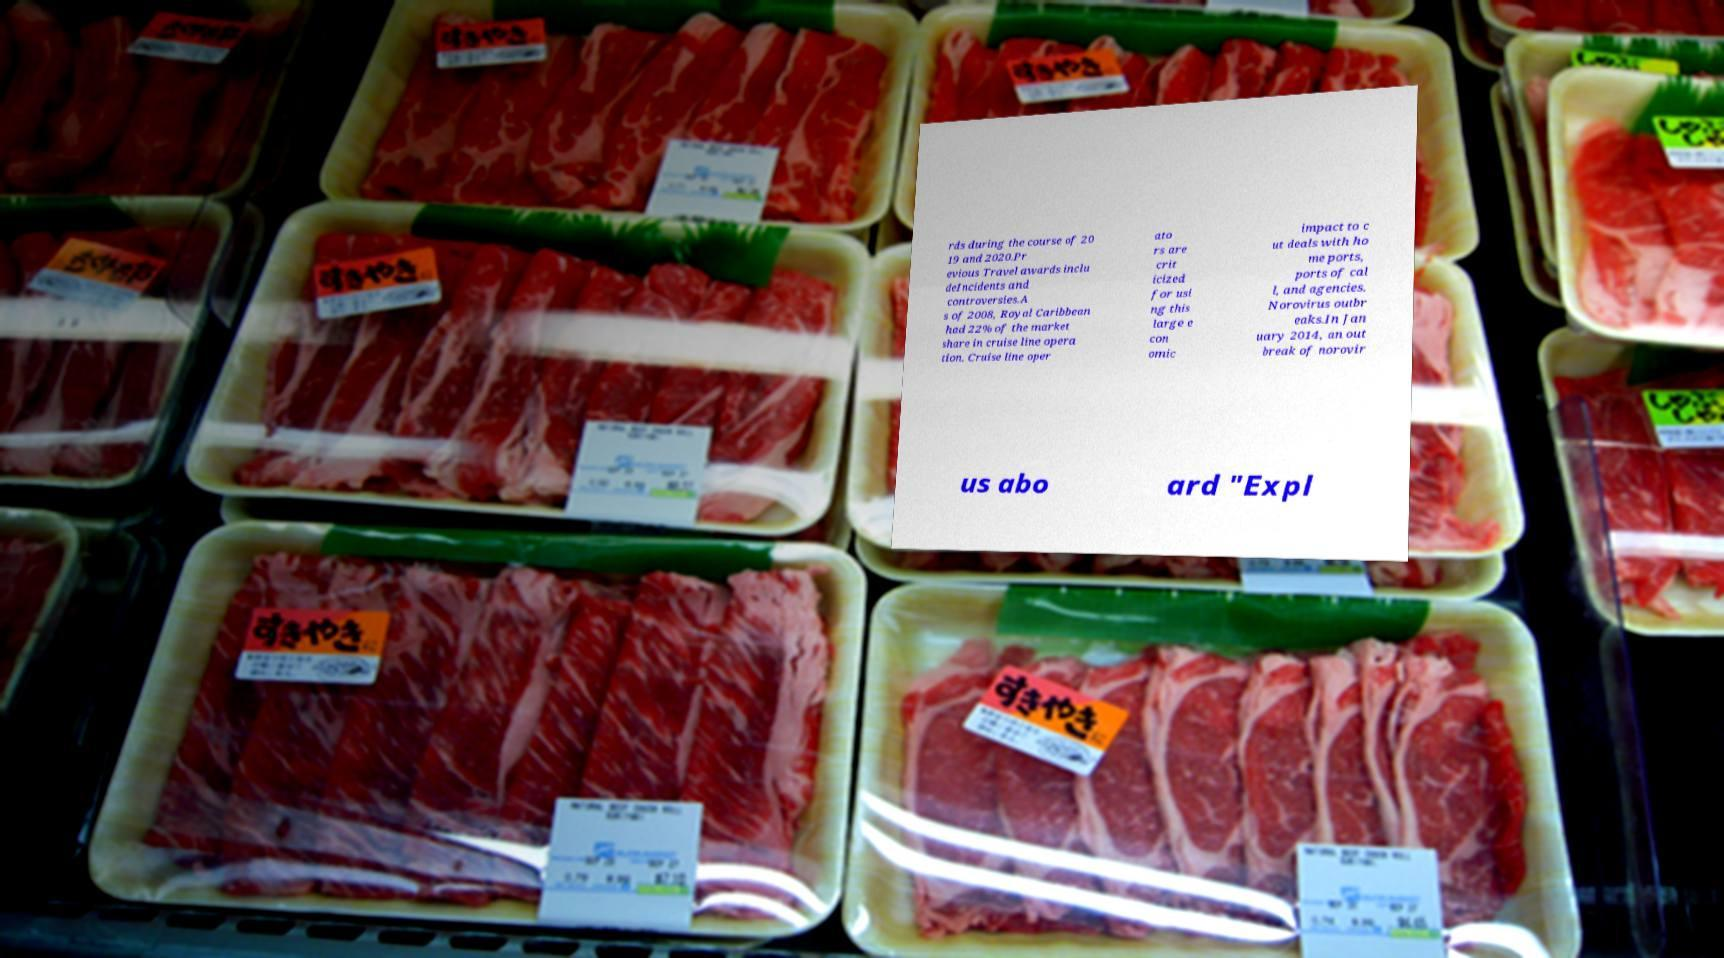I need the written content from this picture converted into text. Can you do that? rds during the course of 20 19 and 2020.Pr evious Travel awards inclu deIncidents and controversies.A s of 2008, Royal Caribbean had 22% of the market share in cruise line opera tion. Cruise line oper ato rs are crit icized for usi ng this large e con omic impact to c ut deals with ho me ports, ports of cal l, and agencies. Norovirus outbr eaks.In Jan uary 2014, an out break of norovir us abo ard "Expl 